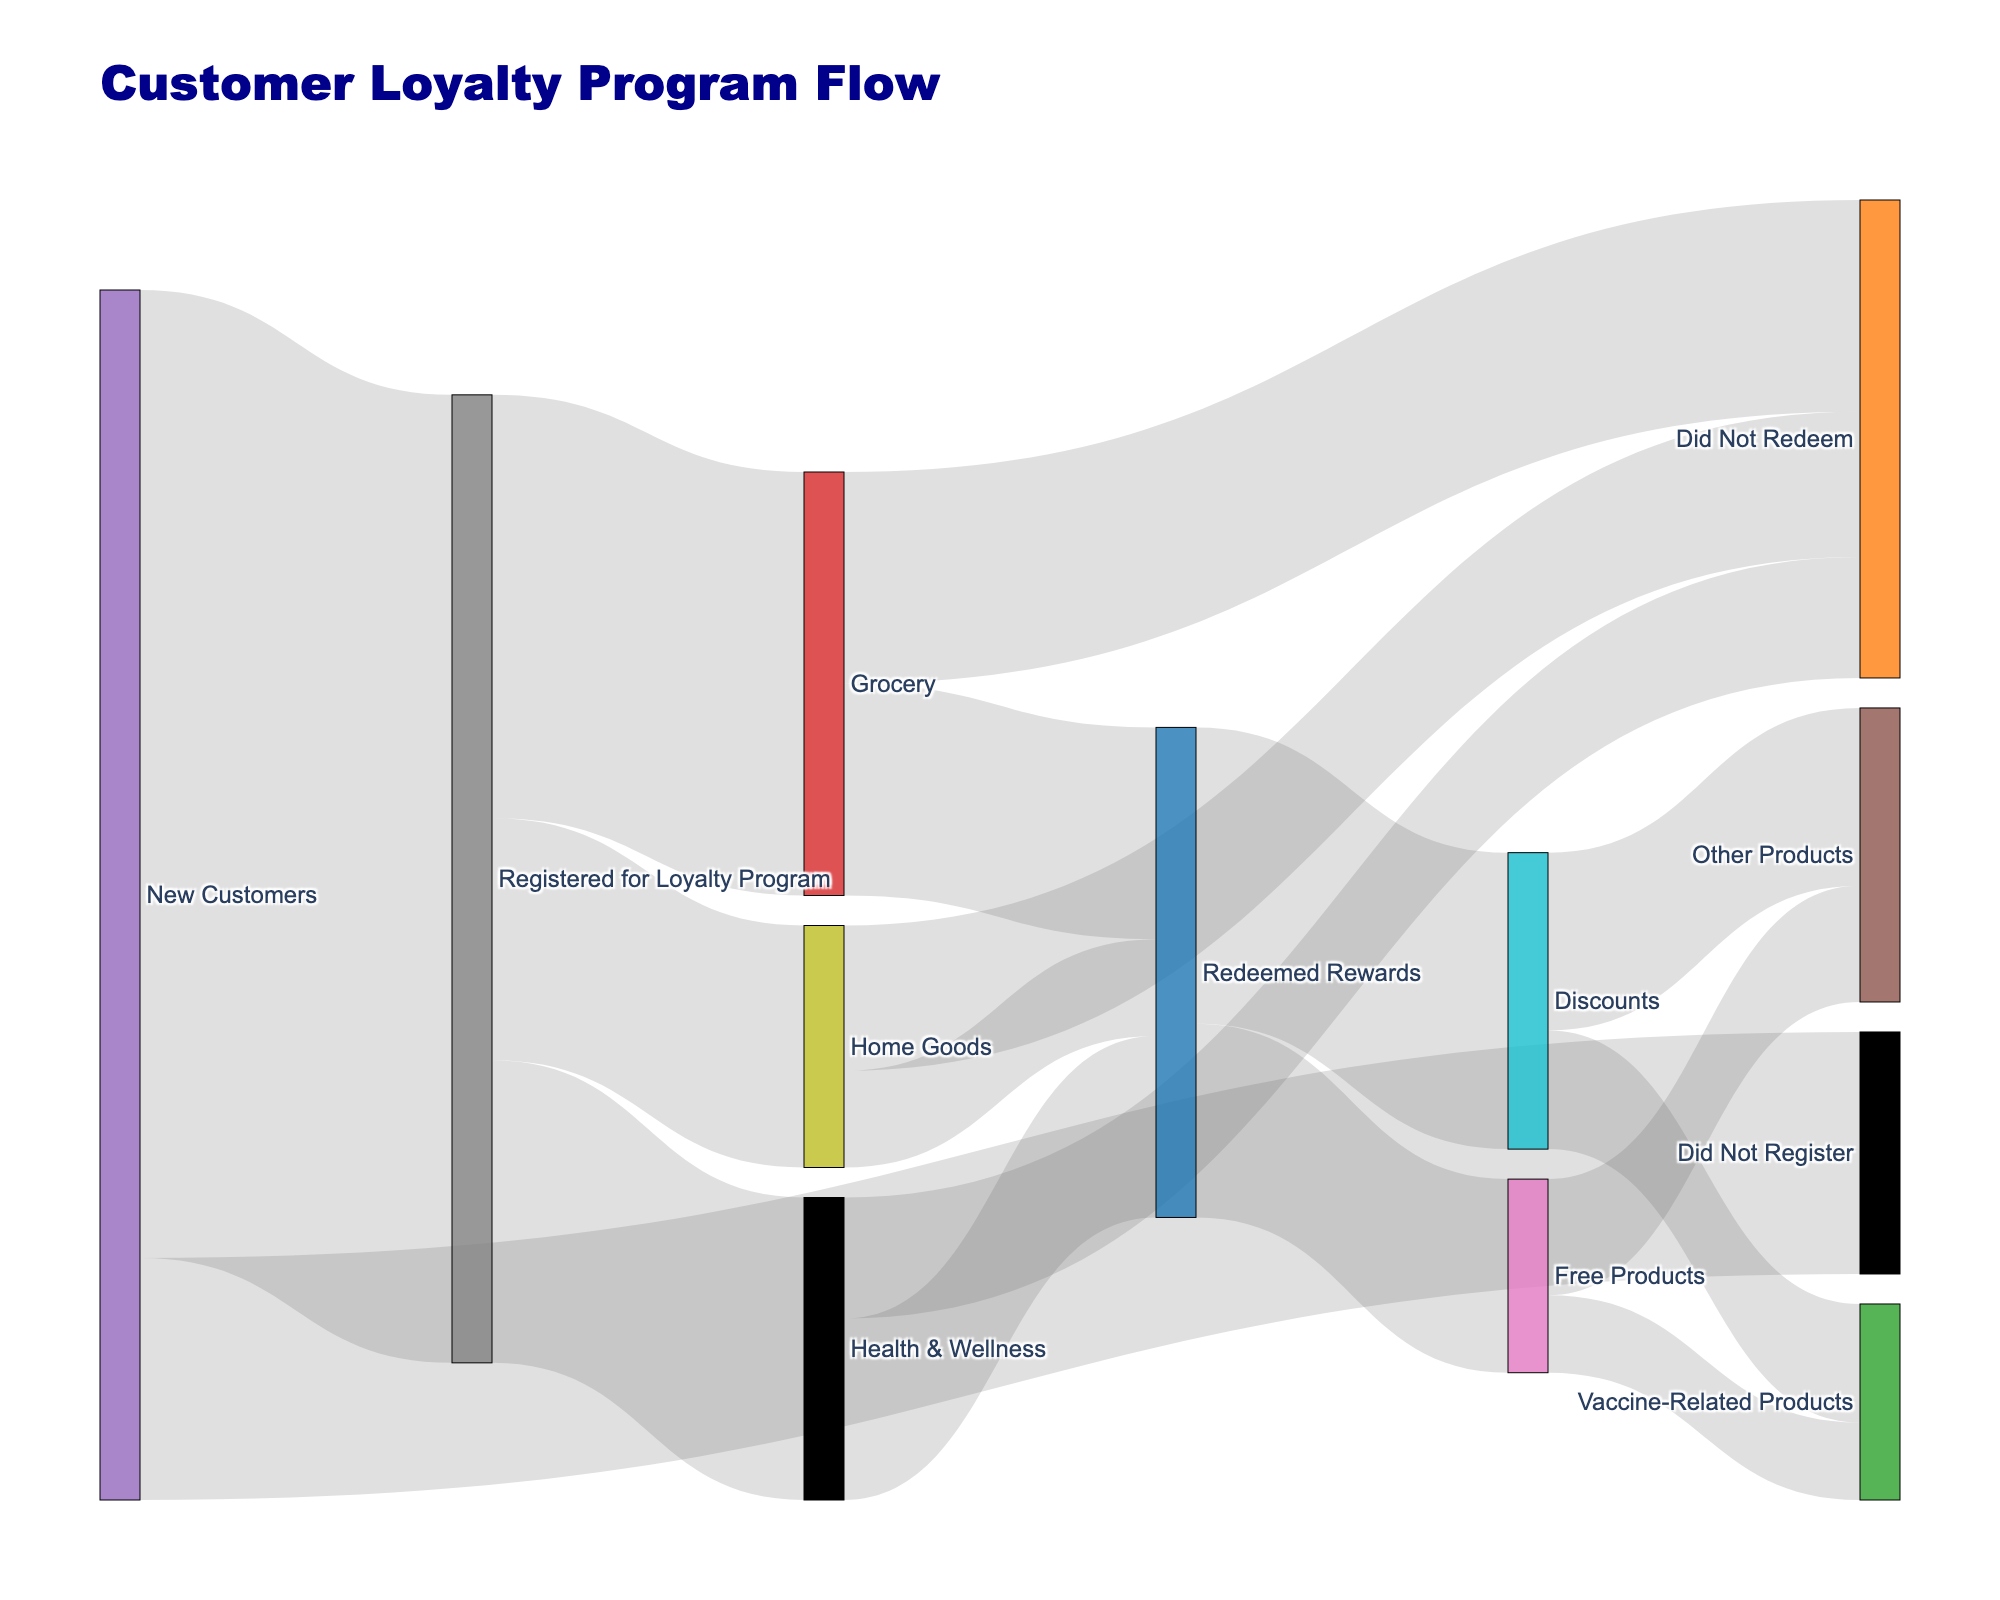What is the total number of new customers? To find the total number of new customers, add those who registered for the loyalty program and those who did not. Therefore, it's 800 (registered) + 200 (did not register).
Answer: 1000 How many customers registered for the loyalty program? The figure directly shows that 800 new customers registered for the loyalty program.
Answer: 800 How does the number of customers who registered for the loyalty program compare to those who did not? The number of customers who registered (800) is much higher than those who did not register (200). The difference is 800 - 200.
Answer: 600 What percentage of registered customers redeemed rewards in the Grocery category? First, find the number of registered customers for the Grocery category (350). Then, find how many redeemed rewards (175). The percentage is (175 / 350) * 100.
Answer: 50% Which product category did the most registered customers participate in? Compare the numbers of registered customers in different categories: Grocery (350), Health & Wellness (250), and Home Goods (200). The Grocery category has the highest.
Answer: Grocery How many customers redeemed rewards from the Health & Wellness category? The diagram shows 150 customers redeemed rewards out of the Health & Wellness category's 250 registered customers.
Answer: 150 What is the total number of customers who did not redeem rewards? Add up the customers who did not redeem rewards from all categories: Grocery (175), Health & Wellness (100), and Home Goods (120). The total is 175 + 100 + 120.
Answer: 395 How many registered customers who redeemed rewards chose vaccine-related products? Add those who chose vaccine-related products from both Discounts (98) and Free Products (64). The total is 98 + 64.
Answer: 162 Which reward type (Discounts or Free Products) was more popular among redeemed rewards? Compare the numbers for Discounts (245) and Free Products (160). Discounts were more popular.
Answer: Discounts What fraction of Grocery registered customers did not redeem rewards? Of the 350 registered customers in Grocery, 175 did not redeem rewards. The fraction is 175 / 350.
Answer: 1/2 